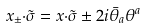<formula> <loc_0><loc_0><loc_500><loc_500>x _ { \pm } { \cdot \tilde { \sigma } } = x { \cdot \tilde { \sigma } } \pm 2 i \bar { \theta } _ { a } \theta ^ { a }</formula> 